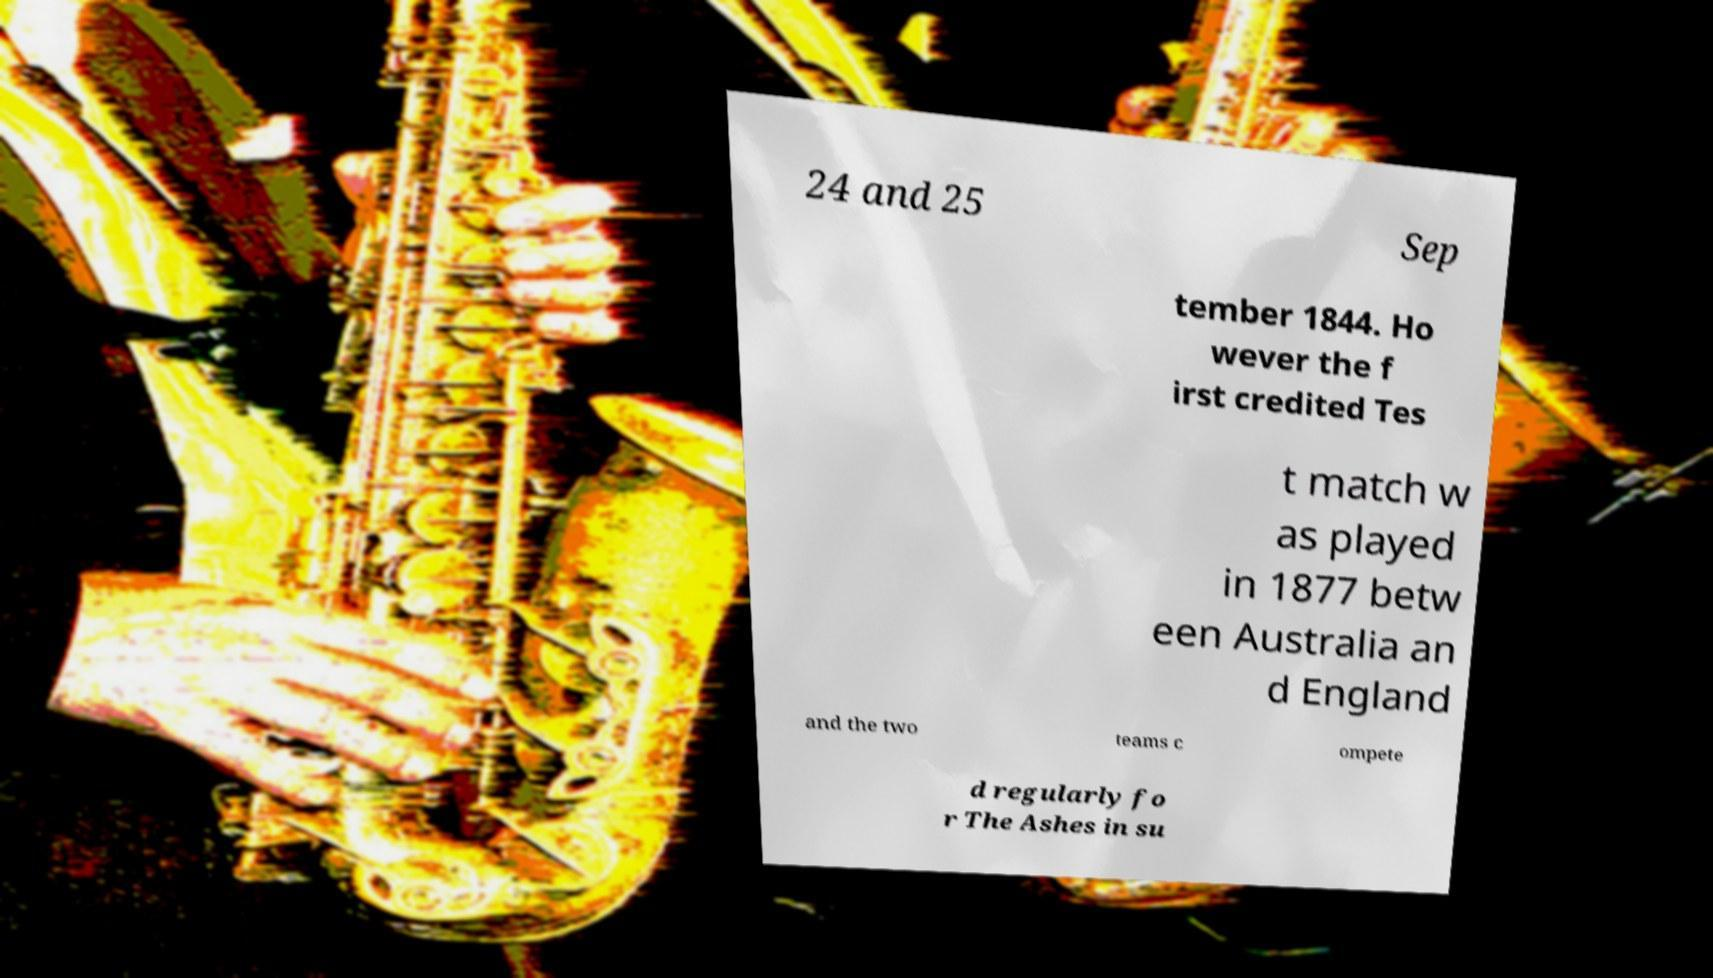What messages or text are displayed in this image? I need them in a readable, typed format. 24 and 25 Sep tember 1844. Ho wever the f irst credited Tes t match w as played in 1877 betw een Australia an d England and the two teams c ompete d regularly fo r The Ashes in su 